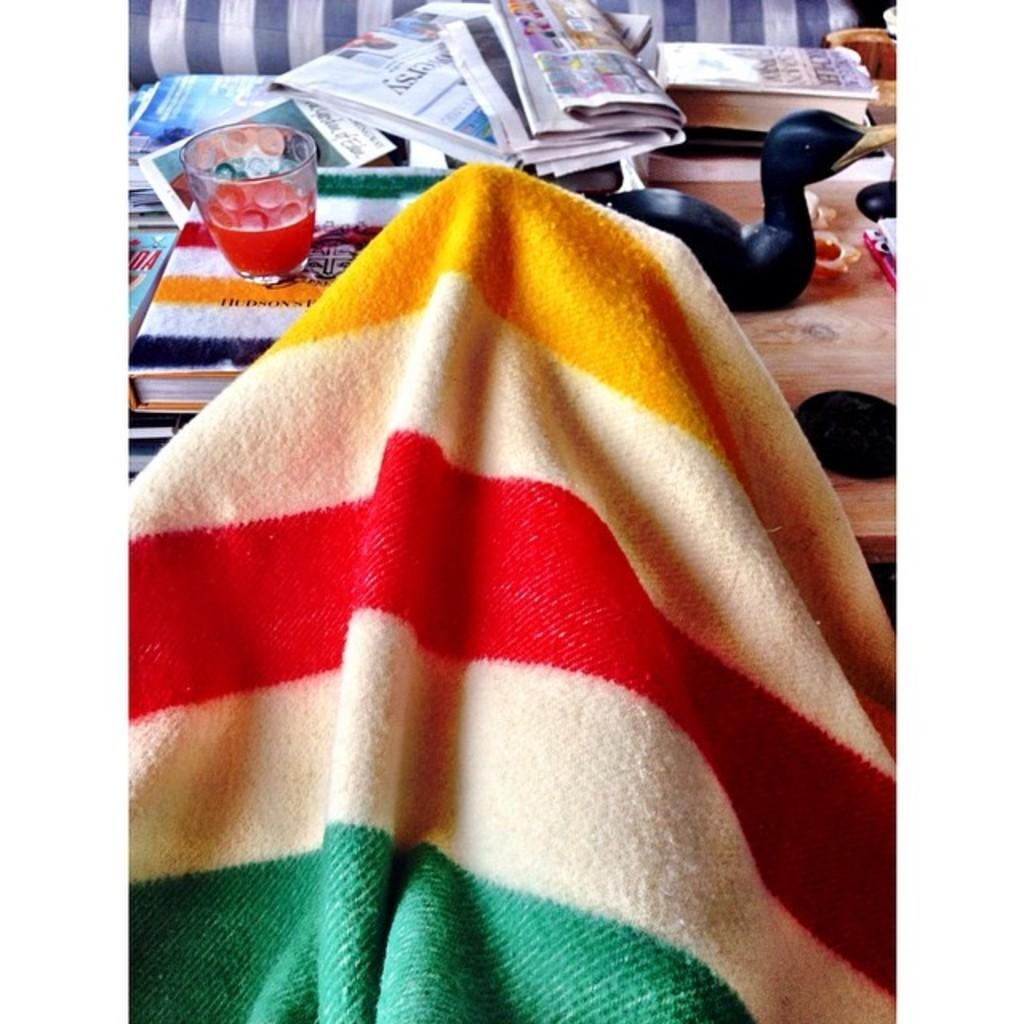What is the main object in the image? There is a cloth in the image. What can be seen in the background of the image? There is a table, books, newspapers, a glass, a toy, and other objects in the background of the image. Can you describe the table in the background? The table is in the background of the image, but no specific details about its appearance are provided. What type of government is depicted in the image? There is no depiction of a government in the image; it features a cloth and various objects in the background. How many sticks are visible in the image? There are no sticks present in the image. 